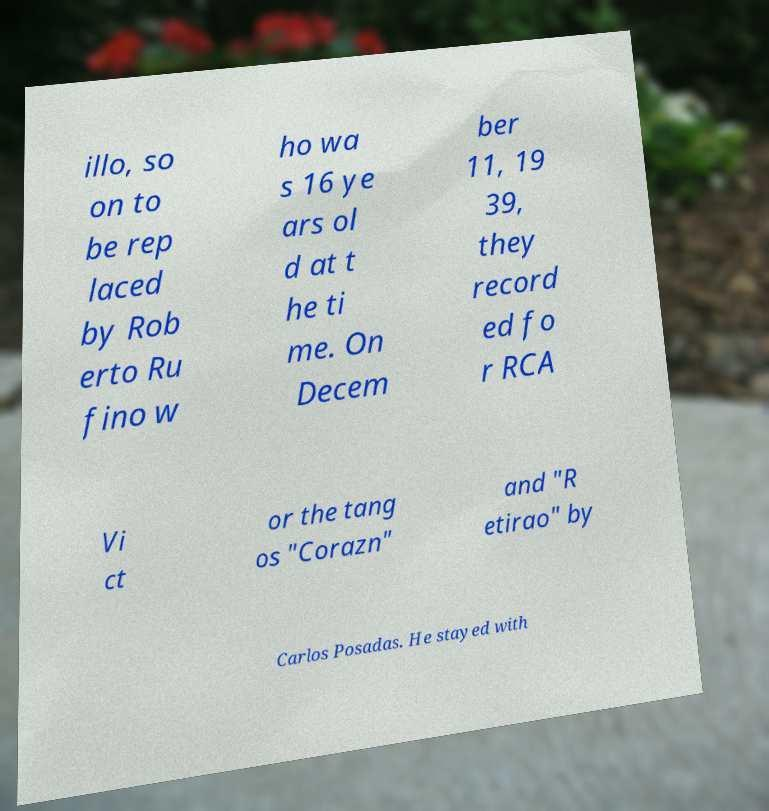Please read and relay the text visible in this image. What does it say? illo, so on to be rep laced by Rob erto Ru fino w ho wa s 16 ye ars ol d at t he ti me. On Decem ber 11, 19 39, they record ed fo r RCA Vi ct or the tang os "Corazn" and "R etirao" by Carlos Posadas. He stayed with 